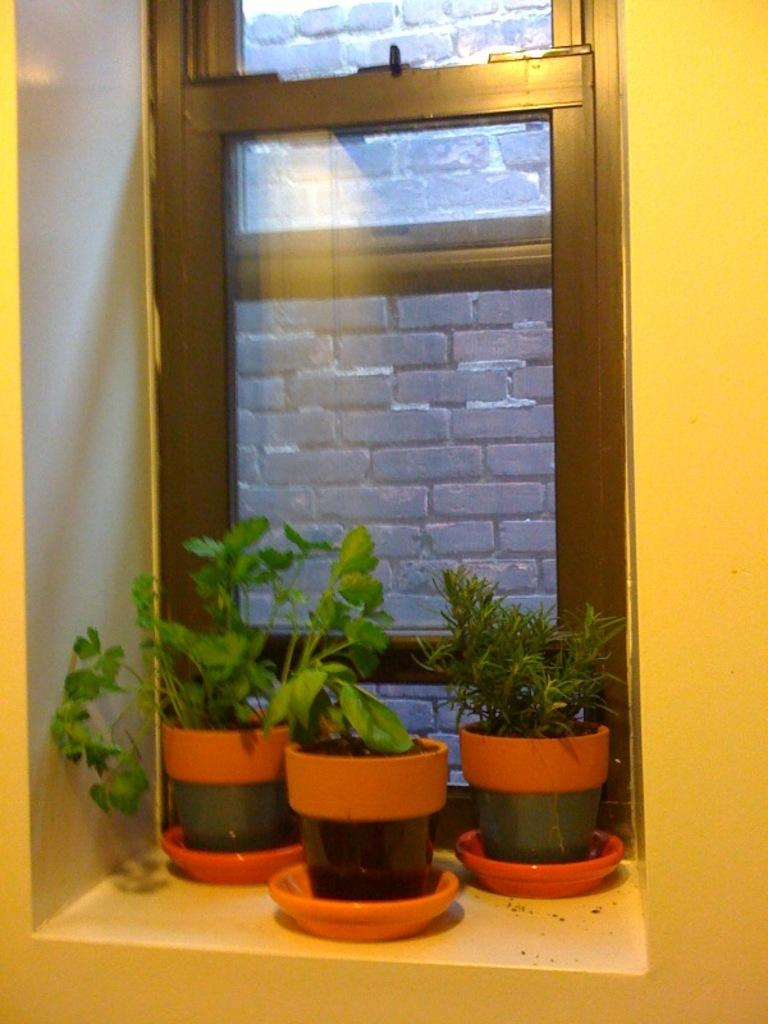How many plants are visible in the image? There are three plants in the image. What are the plants placed in? The plants are placed in plant pots. What can be seen behind the plants? The wall behind the plants is in yellow color. Is there any natural light source visible in the image? Yes, there is a glass window in the image, which suggests natural light is present. What type of spade is being used to dig near the plants in the image? There is no spade or digging activity present in the image; the plants are placed in plant pots. 